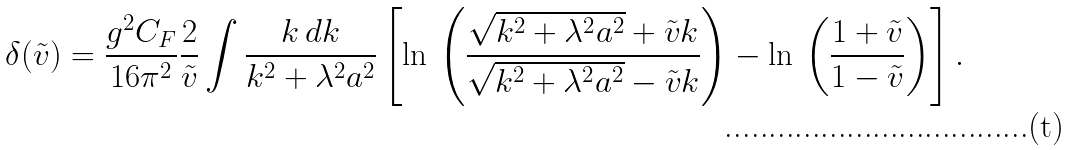<formula> <loc_0><loc_0><loc_500><loc_500>\delta ( \tilde { v } ) = \frac { g ^ { 2 } C _ { F } } { 1 6 \pi ^ { 2 } } \frac { 2 } { \tilde { v } } \int \frac { k \, d k } { k ^ { 2 } + \lambda ^ { 2 } a ^ { 2 } } \left [ \ln \, \left ( \frac { \sqrt { k ^ { 2 } + \lambda ^ { 2 } a ^ { 2 } } + \tilde { v } k } { \sqrt { k ^ { 2 } + \lambda ^ { 2 } a ^ { 2 } } - \tilde { v } k } \right ) - \ln \, \left ( \frac { 1 + \tilde { v } } { 1 - \tilde { v } } \right ) \right ] .</formula> 